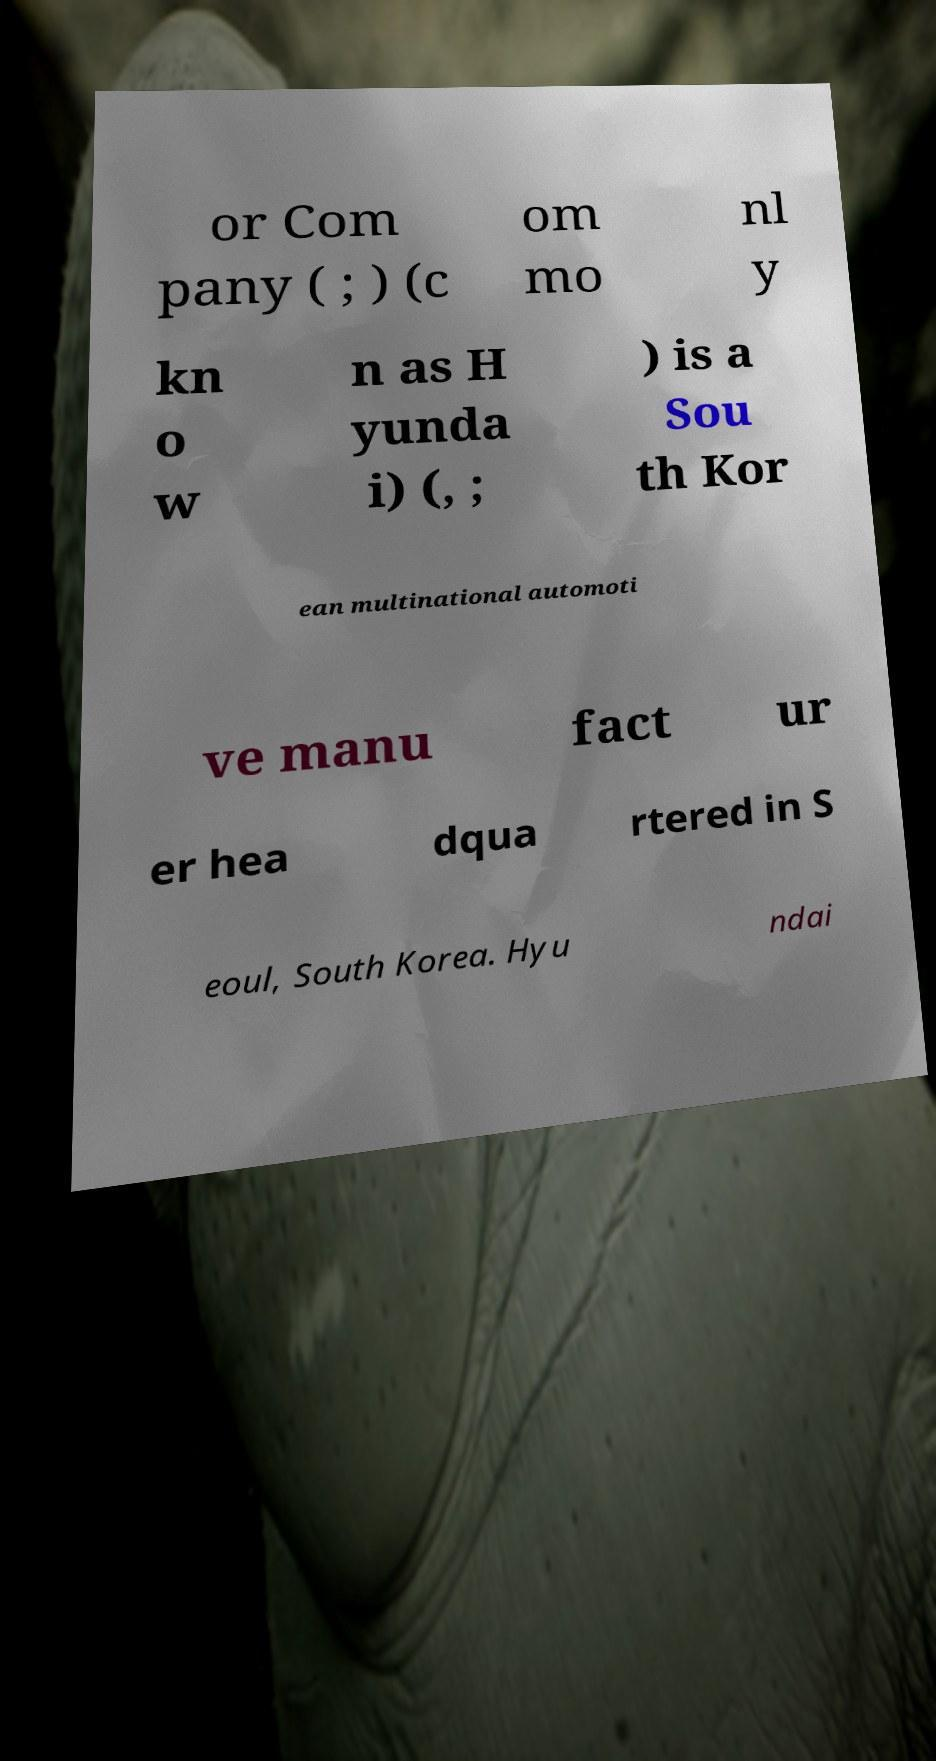Could you extract and type out the text from this image? or Com pany ( ; ) (c om mo nl y kn o w n as H yunda i) (, ; ) is a Sou th Kor ean multinational automoti ve manu fact ur er hea dqua rtered in S eoul, South Korea. Hyu ndai 